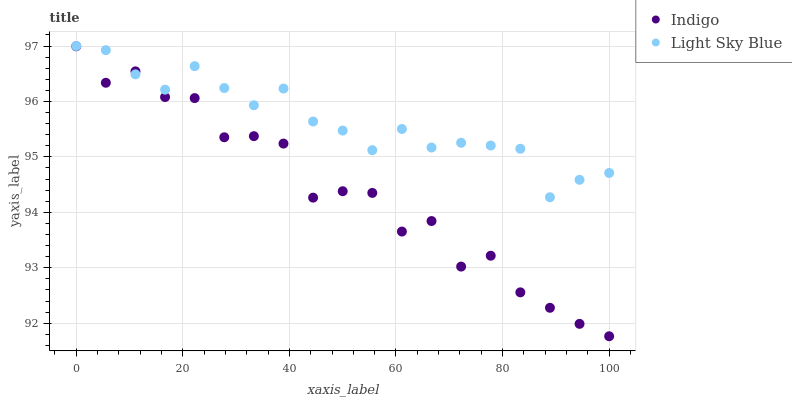Does Indigo have the minimum area under the curve?
Answer yes or no. Yes. Does Light Sky Blue have the maximum area under the curve?
Answer yes or no. Yes. Does Indigo have the maximum area under the curve?
Answer yes or no. No. Is Light Sky Blue the smoothest?
Answer yes or no. Yes. Is Indigo the roughest?
Answer yes or no. Yes. Is Indigo the smoothest?
Answer yes or no. No. Does Indigo have the lowest value?
Answer yes or no. Yes. Does Light Sky Blue have the highest value?
Answer yes or no. Yes. Does Indigo have the highest value?
Answer yes or no. No. Does Light Sky Blue intersect Indigo?
Answer yes or no. Yes. Is Light Sky Blue less than Indigo?
Answer yes or no. No. Is Light Sky Blue greater than Indigo?
Answer yes or no. No. 